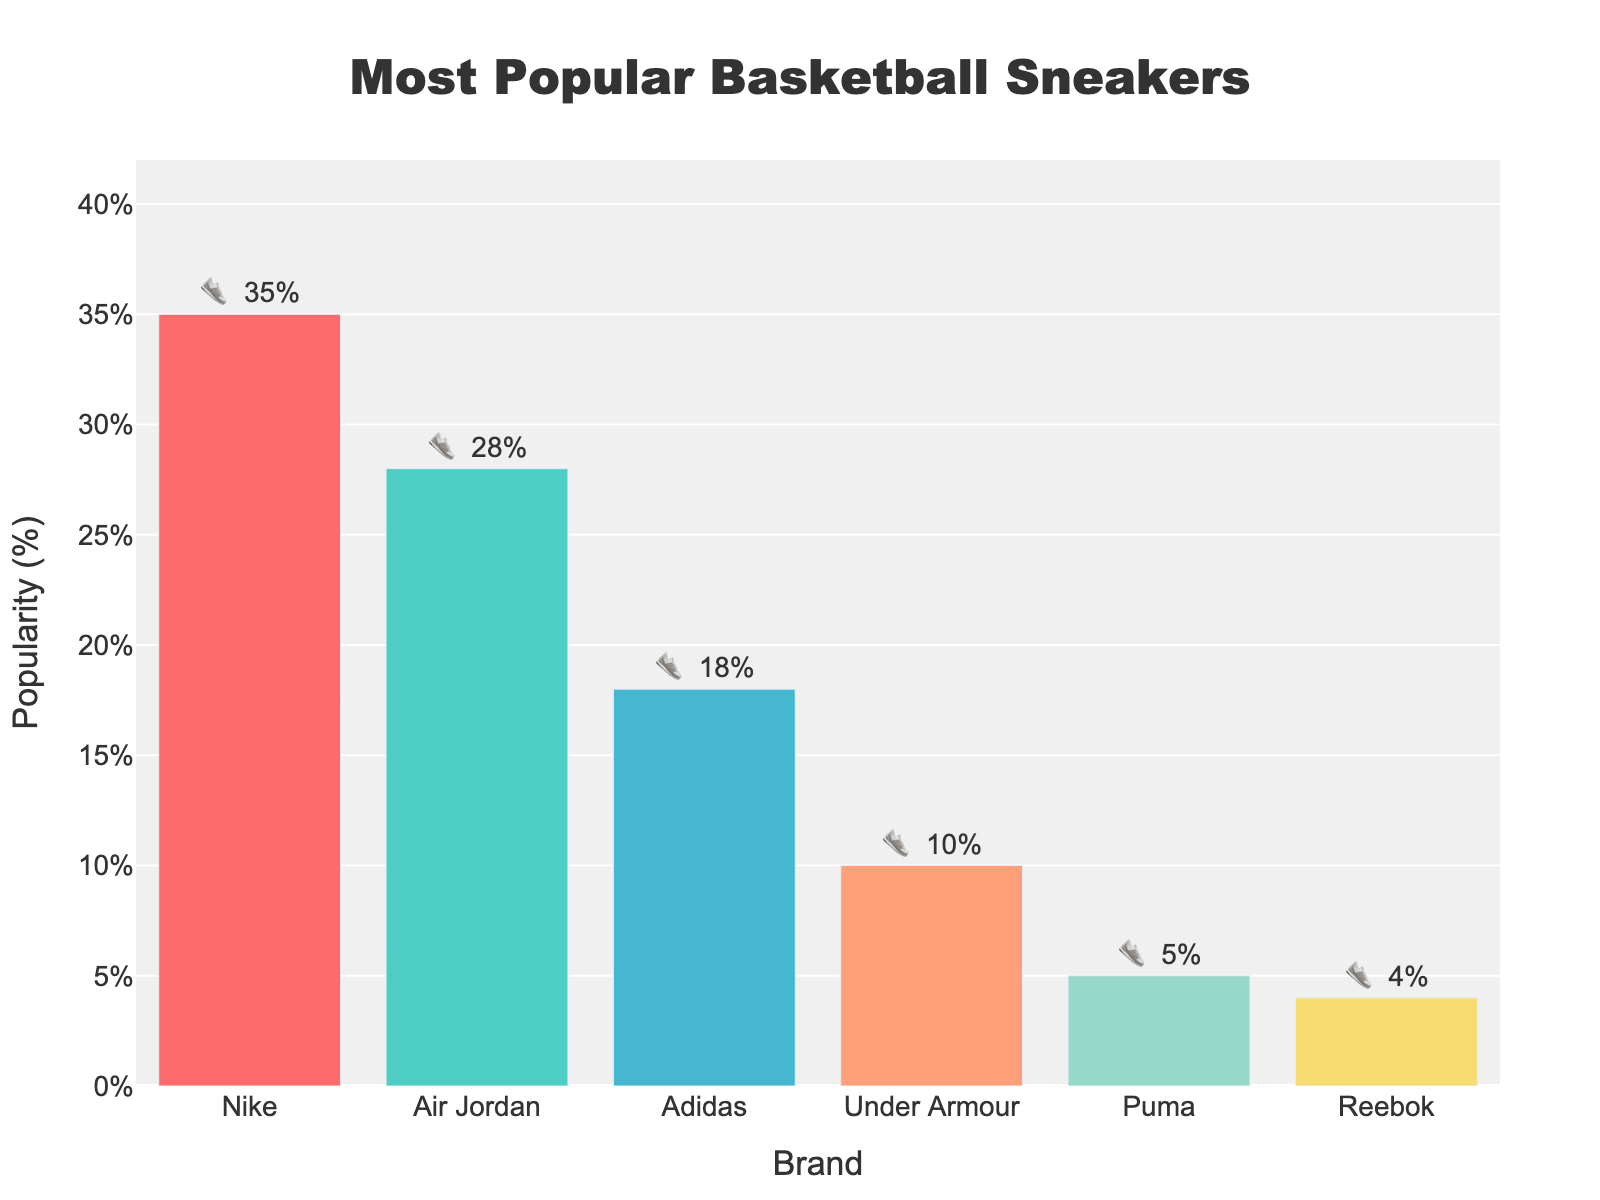Which brand of basketball sneakers is the most popular among players? From the figure, Nike has the highest popularity with 35%.
Answer: Nike How many percentage points more popular are Nike sneakers compared to Adidas sneakers? Nike sneakers are at 35% and Adidas sneakers are at 18%. So, the difference is 35% - 18% = 17 percentage points.
Answer: 17 What is the title of the chart? The title is displayed at the top and reads "Most Popular Basketball Sneakers".
Answer: Most Popular Basketball Sneakers Which brand has the least popular basketball sneakers according to the chart? Reebok is the least popular with 4%.
Answer: Reebok How do the popularity percentages of Under Armour and Puma combined compare to the popularity of Air Jordan? The combined popularity of Under Armour and Puma is 10% + 5% = 15%. Air Jordan's popularity is 28%. Comparing the two: 15% vs. 28%.
Answer: Under Armour and Puma combined are less popular than Air Jordan What is the average popularity percentage of all the brands combined? Summing up all the popularities: 35% + 28% + 18% + 10% + 5% + 4% = 100%. The average is 100% / 6 = 16.67%.
Answer: 16.67% Which brand's bar is colored with the second lightest color in the chart? The second lightest bar in the chart corresponds to Puma.
Answer: Puma Among the brands, which two have the closest popularity percentages? Puma is at 5% and Reebok is at 4%, showing a 1% difference.
Answer: Puma and Reebok By what percentage is Air Jordan more popular than Under Armour? Air Jordan is at 28% and Under Armour is at 10%. The difference is 28% - 10% = 18 percentage points, so Air Jordan is 18 percentage points more popular.
Answer: 18 What combined percentage of players favor Nike, Air Jordan, and Adidas sneakers? The combined percentage is 35% (Nike) + 28% (Air Jordan) + 18% (Adidas) = 81%.
Answer: 81% 